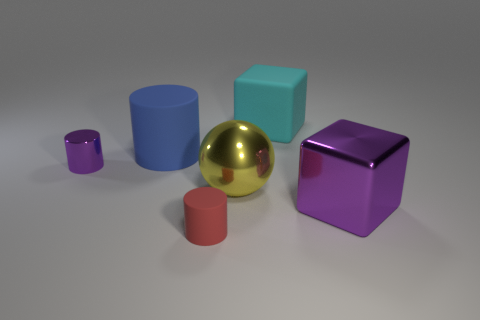There is a metal block that is the same color as the metal cylinder; what size is it?
Your answer should be very brief. Large. There is a blue thing that is the same size as the yellow sphere; what is it made of?
Your answer should be compact. Rubber. There is a small shiny thing that is behind the purple metal cube; is it the same shape as the red rubber thing?
Make the answer very short. Yes. Is the color of the tiny metallic object the same as the big shiny block?
Offer a terse response. Yes. What number of things are cubes in front of the tiny purple thing or large purple metal blocks?
Your response must be concise. 1. What shape is the purple metallic thing that is the same size as the yellow metallic thing?
Your answer should be compact. Cube. Is the size of the matte thing on the right side of the yellow metal ball the same as the matte cylinder that is in front of the small purple cylinder?
Offer a terse response. No. There is a small cylinder that is the same material as the big cylinder; what color is it?
Make the answer very short. Red. Do the block that is in front of the big blue rubber thing and the purple thing that is left of the blue thing have the same material?
Offer a terse response. Yes. Is there a purple metal thing that has the same size as the cyan matte thing?
Provide a short and direct response. Yes. 